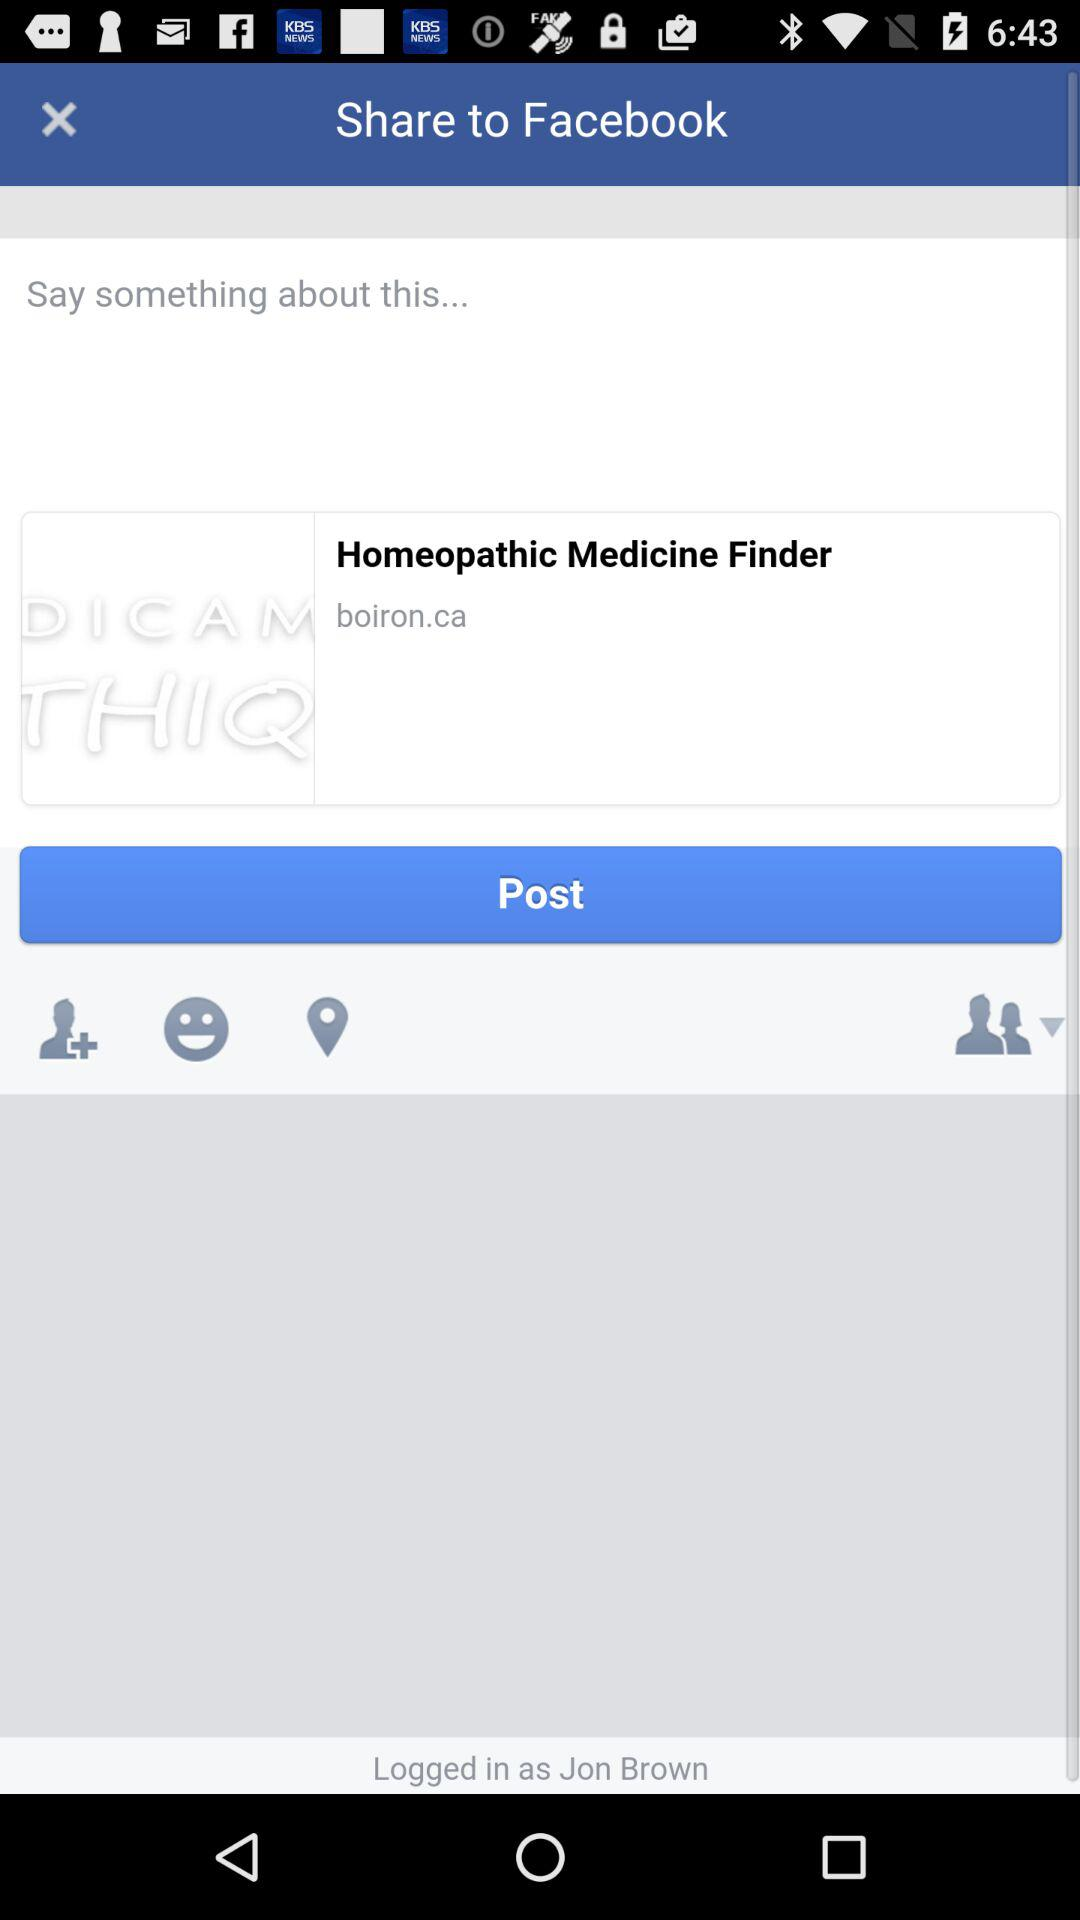What application are we using to share? The application is "Facebook". 